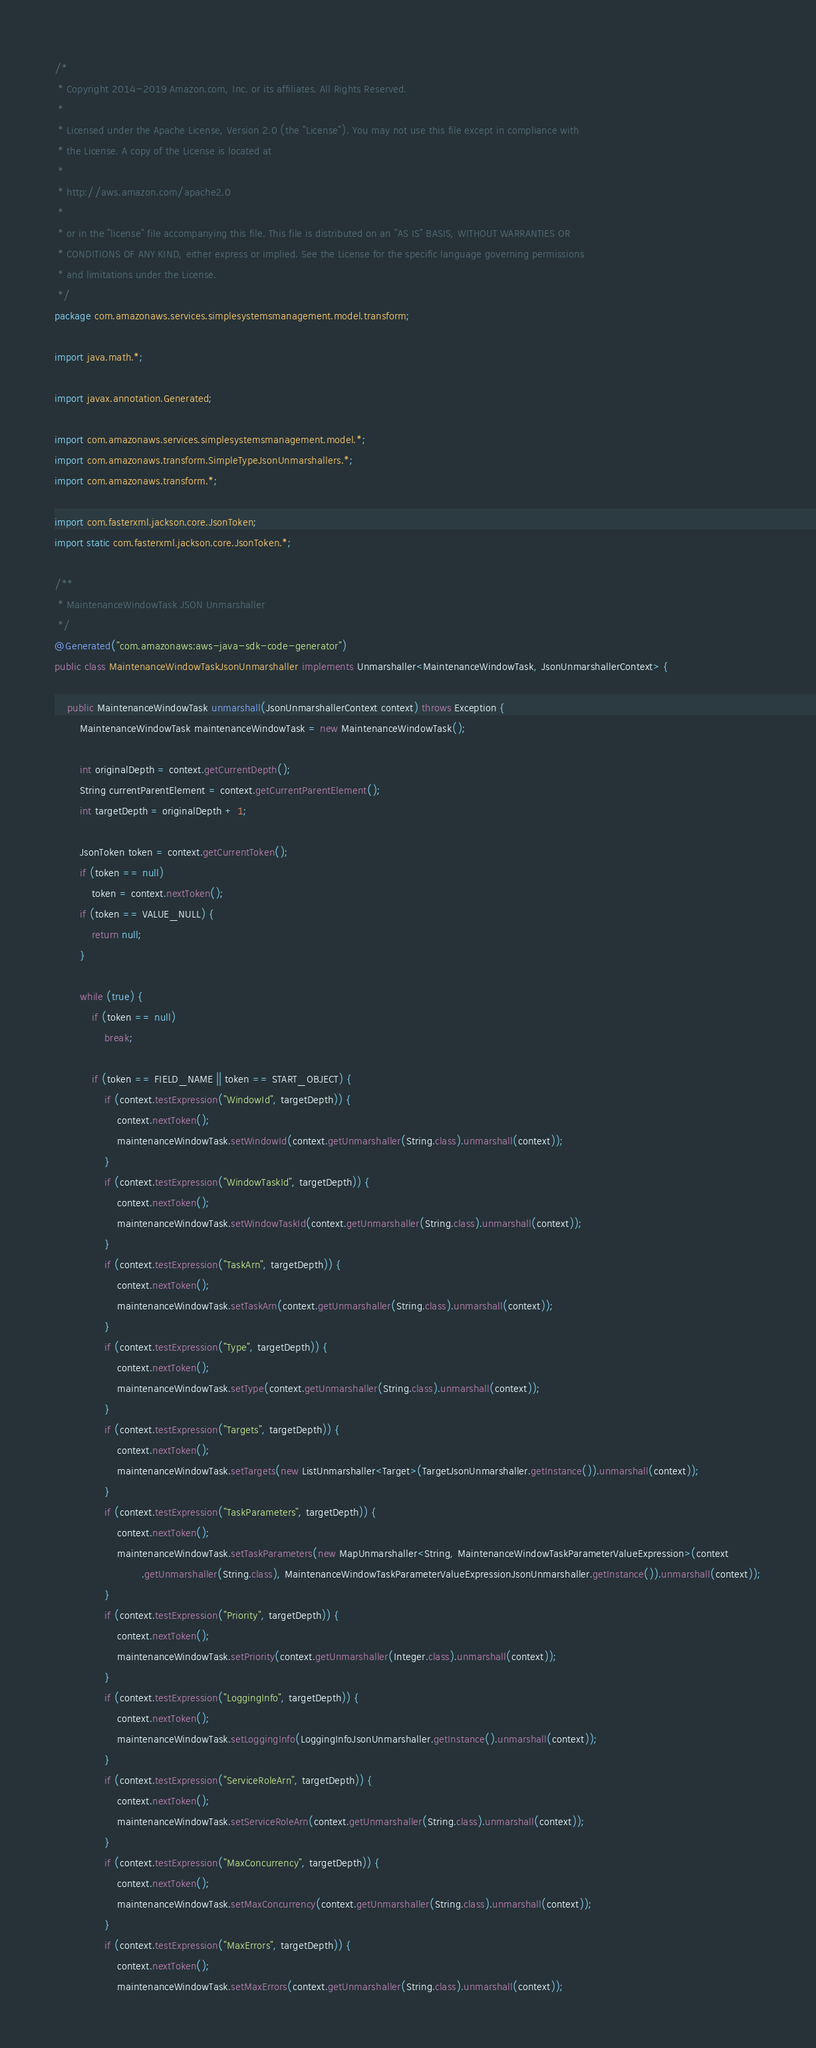Convert code to text. <code><loc_0><loc_0><loc_500><loc_500><_Java_>/*
 * Copyright 2014-2019 Amazon.com, Inc. or its affiliates. All Rights Reserved.
 * 
 * Licensed under the Apache License, Version 2.0 (the "License"). You may not use this file except in compliance with
 * the License. A copy of the License is located at
 * 
 * http://aws.amazon.com/apache2.0
 * 
 * or in the "license" file accompanying this file. This file is distributed on an "AS IS" BASIS, WITHOUT WARRANTIES OR
 * CONDITIONS OF ANY KIND, either express or implied. See the License for the specific language governing permissions
 * and limitations under the License.
 */
package com.amazonaws.services.simplesystemsmanagement.model.transform;

import java.math.*;

import javax.annotation.Generated;

import com.amazonaws.services.simplesystemsmanagement.model.*;
import com.amazonaws.transform.SimpleTypeJsonUnmarshallers.*;
import com.amazonaws.transform.*;

import com.fasterxml.jackson.core.JsonToken;
import static com.fasterxml.jackson.core.JsonToken.*;

/**
 * MaintenanceWindowTask JSON Unmarshaller
 */
@Generated("com.amazonaws:aws-java-sdk-code-generator")
public class MaintenanceWindowTaskJsonUnmarshaller implements Unmarshaller<MaintenanceWindowTask, JsonUnmarshallerContext> {

    public MaintenanceWindowTask unmarshall(JsonUnmarshallerContext context) throws Exception {
        MaintenanceWindowTask maintenanceWindowTask = new MaintenanceWindowTask();

        int originalDepth = context.getCurrentDepth();
        String currentParentElement = context.getCurrentParentElement();
        int targetDepth = originalDepth + 1;

        JsonToken token = context.getCurrentToken();
        if (token == null)
            token = context.nextToken();
        if (token == VALUE_NULL) {
            return null;
        }

        while (true) {
            if (token == null)
                break;

            if (token == FIELD_NAME || token == START_OBJECT) {
                if (context.testExpression("WindowId", targetDepth)) {
                    context.nextToken();
                    maintenanceWindowTask.setWindowId(context.getUnmarshaller(String.class).unmarshall(context));
                }
                if (context.testExpression("WindowTaskId", targetDepth)) {
                    context.nextToken();
                    maintenanceWindowTask.setWindowTaskId(context.getUnmarshaller(String.class).unmarshall(context));
                }
                if (context.testExpression("TaskArn", targetDepth)) {
                    context.nextToken();
                    maintenanceWindowTask.setTaskArn(context.getUnmarshaller(String.class).unmarshall(context));
                }
                if (context.testExpression("Type", targetDepth)) {
                    context.nextToken();
                    maintenanceWindowTask.setType(context.getUnmarshaller(String.class).unmarshall(context));
                }
                if (context.testExpression("Targets", targetDepth)) {
                    context.nextToken();
                    maintenanceWindowTask.setTargets(new ListUnmarshaller<Target>(TargetJsonUnmarshaller.getInstance()).unmarshall(context));
                }
                if (context.testExpression("TaskParameters", targetDepth)) {
                    context.nextToken();
                    maintenanceWindowTask.setTaskParameters(new MapUnmarshaller<String, MaintenanceWindowTaskParameterValueExpression>(context
                            .getUnmarshaller(String.class), MaintenanceWindowTaskParameterValueExpressionJsonUnmarshaller.getInstance()).unmarshall(context));
                }
                if (context.testExpression("Priority", targetDepth)) {
                    context.nextToken();
                    maintenanceWindowTask.setPriority(context.getUnmarshaller(Integer.class).unmarshall(context));
                }
                if (context.testExpression("LoggingInfo", targetDepth)) {
                    context.nextToken();
                    maintenanceWindowTask.setLoggingInfo(LoggingInfoJsonUnmarshaller.getInstance().unmarshall(context));
                }
                if (context.testExpression("ServiceRoleArn", targetDepth)) {
                    context.nextToken();
                    maintenanceWindowTask.setServiceRoleArn(context.getUnmarshaller(String.class).unmarshall(context));
                }
                if (context.testExpression("MaxConcurrency", targetDepth)) {
                    context.nextToken();
                    maintenanceWindowTask.setMaxConcurrency(context.getUnmarshaller(String.class).unmarshall(context));
                }
                if (context.testExpression("MaxErrors", targetDepth)) {
                    context.nextToken();
                    maintenanceWindowTask.setMaxErrors(context.getUnmarshaller(String.class).unmarshall(context));</code> 